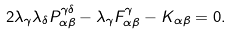Convert formula to latex. <formula><loc_0><loc_0><loc_500><loc_500>2 \lambda _ { \gamma } \lambda _ { \delta } P _ { \alpha \beta } ^ { \gamma \delta } - \lambda _ { \gamma } F _ { \alpha \beta } ^ { \gamma } - K _ { \alpha \beta } = 0 .</formula> 